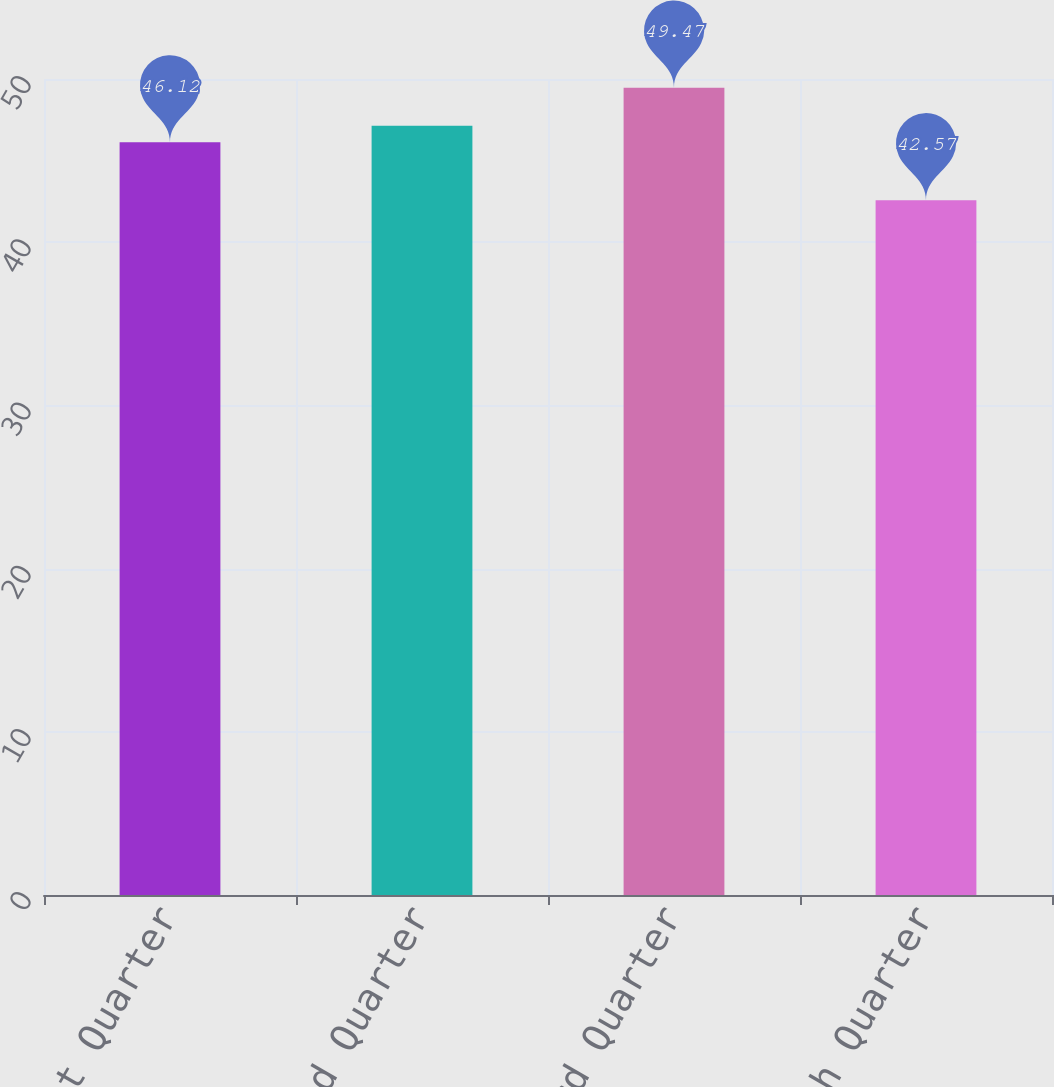<chart> <loc_0><loc_0><loc_500><loc_500><bar_chart><fcel>First Quarter<fcel>Second Quarter<fcel>Third Quarter<fcel>Fourth Quarter<nl><fcel>46.12<fcel>47.14<fcel>49.47<fcel>42.57<nl></chart> 